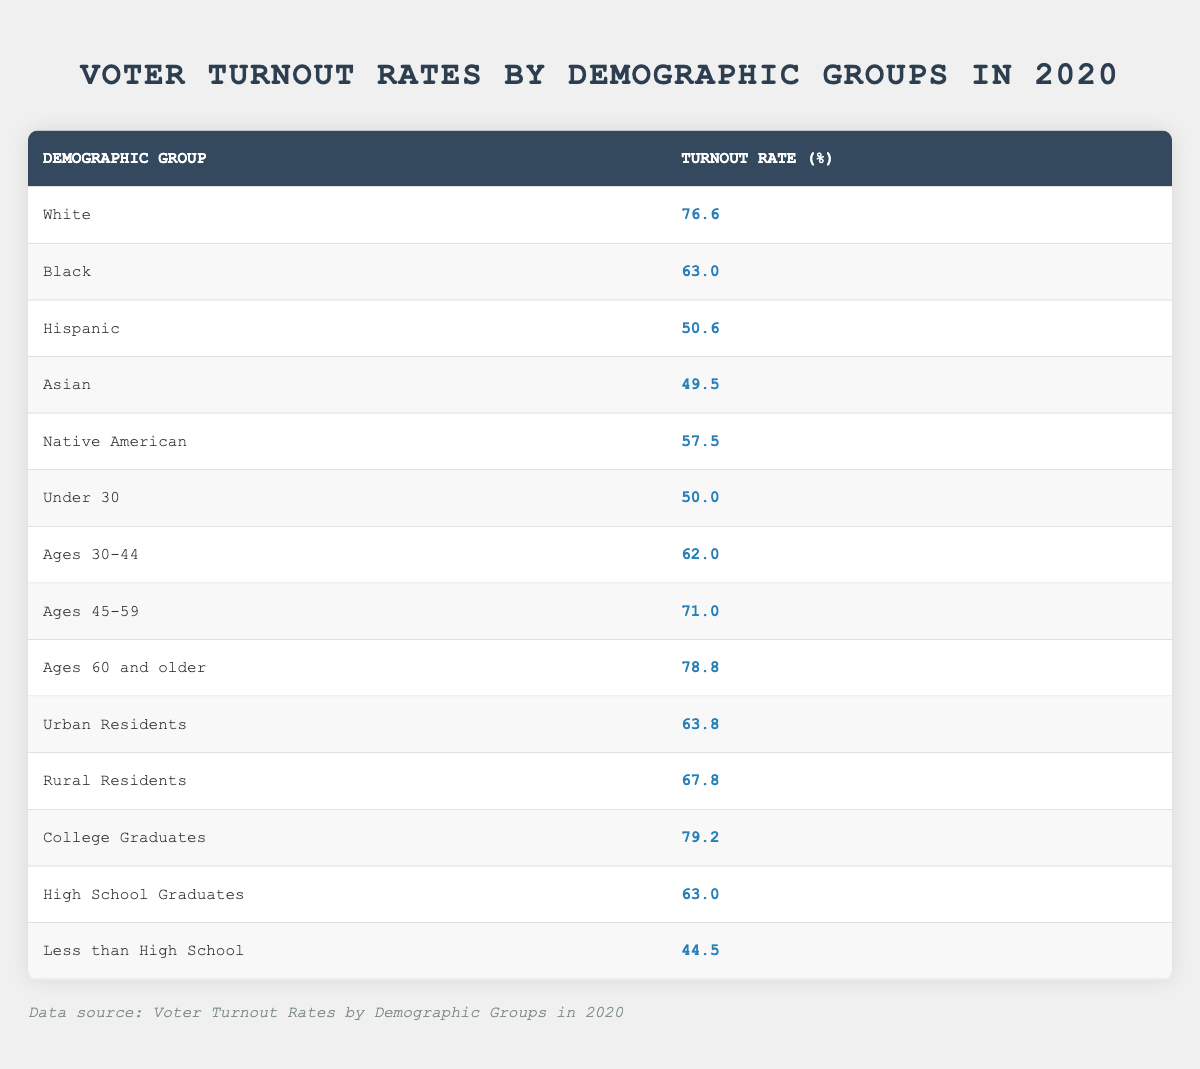What was the voter turnout rate for White individuals in 2020? The table indicates that the voter turnout rate for the demographic group "White" was **76.6%**.
Answer: 76.6% What is the voter turnout rate for College Graduates? According to the table, the turnout rate for College Graduates was recorded as **79.2%**.
Answer: 79.2% Which demographic group had the lowest voter turnout rate? The table shows that the "Less than High School" group had the lowest voter turnout rate at **44.5%**.
Answer: 44.5% What is the difference in voter turnout rates between Hispanic and Black individuals? To find the difference, we subtract the Hispanic turnout rate (50.6%) from the Black turnout rate (63.0%). The calculation gives us 63.0 - 50.6 = **12.4%**.
Answer: 12.4% Is the voter turnout rate for Rural Residents higher than that for Urban Residents? The table lists Rural Residents' turnout at **67.8%** and Urban Residents' turnout at **63.8%**. Since 67.8% is greater than 63.8%, the statement is true.
Answer: Yes What is the average voter turnout rate for individuals aged 30-44 and 45-59? We first locate the two groups: Ages 30-44 with a turnout of **62.0%** and Ages 45-59 with a turnout of **71.0%**. To find the average, we total them: 62.0 + 71.0 = 133.0, and then divide by 2, giving us 133.0 / 2 = **66.5%**.
Answer: 66.5% How does the voter turnout rate for individuals aged 60 and older compare to that of College Graduates? The turnout rate for those aged 60 and older is **78.8%**, and the rate for College Graduates is **79.2%**. Since 78.8% is slightly less than 79.2%, College Graduates have a higher turnout rate.
Answer: College Graduates have a higher turnout What can we infer about voter turnout rates for younger individuals (Under 30) compared to older individuals (60 and older)? The Under 30 group has a turnout rate of **50.0%**, whereas the 60 and older group has a much higher rate of **78.8%**. This indicates that older individuals are more likely to vote than younger individuals.
Answer: Older individuals are more likely to vote What percentage of Native Americans turned out to vote in 2020? The table shows that the voter turnout rate for Native Americans was **57.5%** in 2020.
Answer: 57.5% What is the voter turnout rate for individuals with less than a high school education? According to the table, the turnout rate for individuals with less than a high school education is **44.5%**.
Answer: 44.5% Which demographic group had a higher turnout rate: Hispanic or Asian individuals? The table lists Hispanic individuals with a turnout rate of **50.6%** and Asian individuals with **49.5%**. Since 50.6% is greater, Hispanic individuals had a higher turnout.
Answer: Hispanic individuals had a higher turnout 